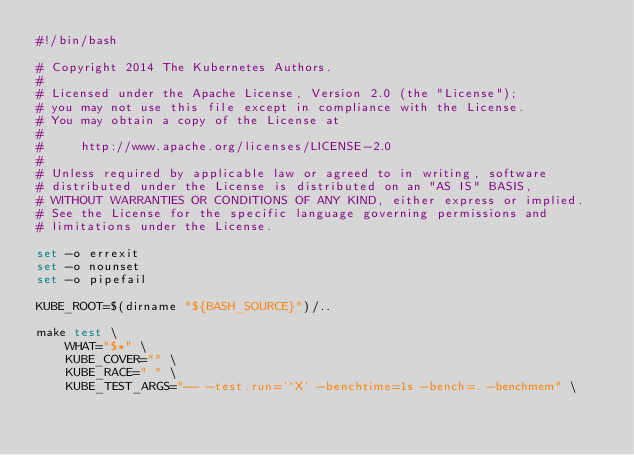<code> <loc_0><loc_0><loc_500><loc_500><_Bash_>#!/bin/bash

# Copyright 2014 The Kubernetes Authors.
#
# Licensed under the Apache License, Version 2.0 (the "License");
# you may not use this file except in compliance with the License.
# You may obtain a copy of the License at
#
#     http://www.apache.org/licenses/LICENSE-2.0
#
# Unless required by applicable law or agreed to in writing, software
# distributed under the License is distributed on an "AS IS" BASIS,
# WITHOUT WARRANTIES OR CONDITIONS OF ANY KIND, either express or implied.
# See the License for the specific language governing permissions and
# limitations under the License.

set -o errexit
set -o nounset
set -o pipefail

KUBE_ROOT=$(dirname "${BASH_SOURCE}")/..

make test \
    WHAT="$*" \
    KUBE_COVER="" \
    KUBE_RACE=" " \
    KUBE_TEST_ARGS="-- -test.run='^X' -benchtime=1s -bench=. -benchmem" \
</code> 